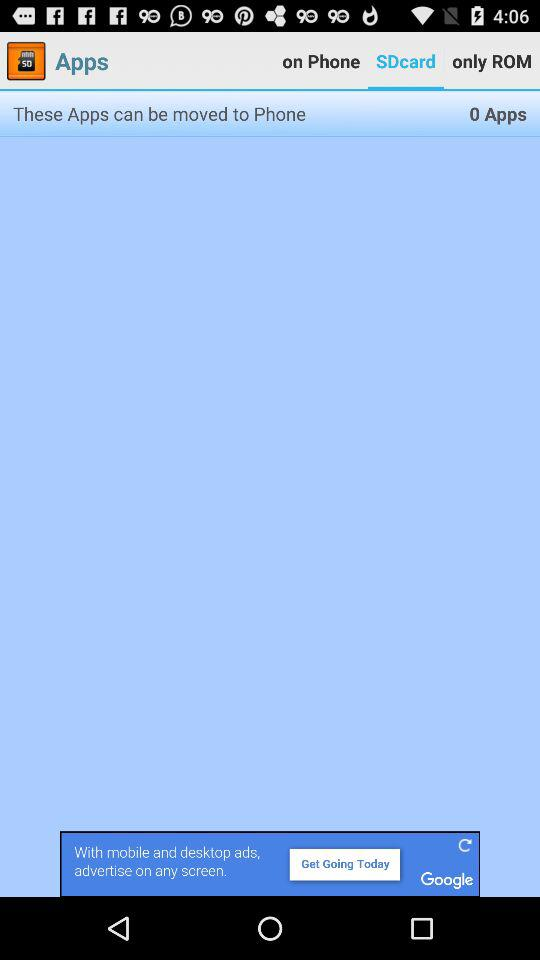How many apps are on the phone?
Answer the question using a single word or phrase. 0 